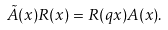Convert formula to latex. <formula><loc_0><loc_0><loc_500><loc_500>\tilde { A } ( x ) R ( x ) = R ( q x ) A ( x ) .</formula> 